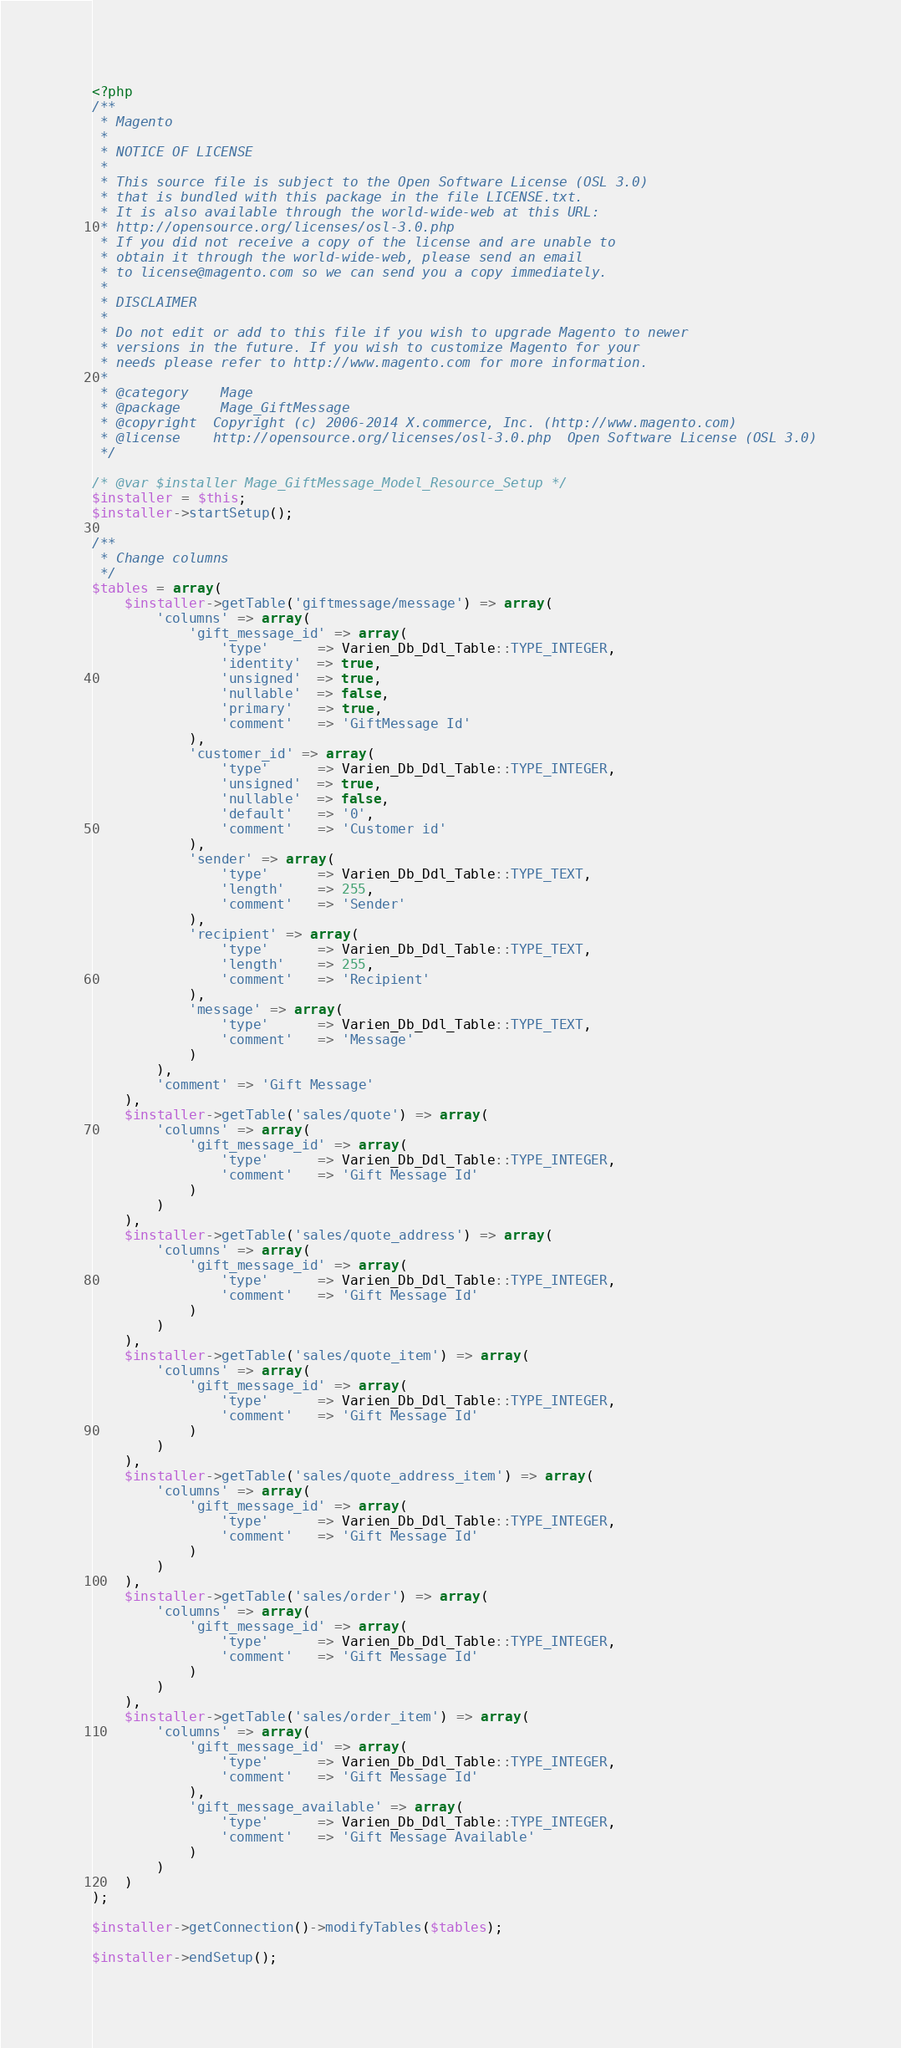Convert code to text. <code><loc_0><loc_0><loc_500><loc_500><_PHP_><?php
/**
 * Magento
 *
 * NOTICE OF LICENSE
 *
 * This source file is subject to the Open Software License (OSL 3.0)
 * that is bundled with this package in the file LICENSE.txt.
 * It is also available through the world-wide-web at this URL:
 * http://opensource.org/licenses/osl-3.0.php
 * If you did not receive a copy of the license and are unable to
 * obtain it through the world-wide-web, please send an email
 * to license@magento.com so we can send you a copy immediately.
 *
 * DISCLAIMER
 *
 * Do not edit or add to this file if you wish to upgrade Magento to newer
 * versions in the future. If you wish to customize Magento for your
 * needs please refer to http://www.magento.com for more information.
 *
 * @category    Mage
 * @package     Mage_GiftMessage
 * @copyright  Copyright (c) 2006-2014 X.commerce, Inc. (http://www.magento.com)
 * @license    http://opensource.org/licenses/osl-3.0.php  Open Software License (OSL 3.0)
 */

/* @var $installer Mage_GiftMessage_Model_Resource_Setup */
$installer = $this;
$installer->startSetup();

/**
 * Change columns
 */
$tables = array(
    $installer->getTable('giftmessage/message') => array(
        'columns' => array(
            'gift_message_id' => array(
                'type'      => Varien_Db_Ddl_Table::TYPE_INTEGER,
                'identity'  => true,
                'unsigned'  => true,
                'nullable'  => false,
                'primary'   => true,
                'comment'   => 'GiftMessage Id'
            ),
            'customer_id' => array(
                'type'      => Varien_Db_Ddl_Table::TYPE_INTEGER,
                'unsigned'  => true,
                'nullable'  => false,
                'default'   => '0',
                'comment'   => 'Customer id'
            ),
            'sender' => array(
                'type'      => Varien_Db_Ddl_Table::TYPE_TEXT,
                'length'    => 255,
                'comment'   => 'Sender'
            ),
            'recipient' => array(
                'type'      => Varien_Db_Ddl_Table::TYPE_TEXT,
                'length'    => 255,
                'comment'   => 'Recipient'
            ),
            'message' => array(
                'type'      => Varien_Db_Ddl_Table::TYPE_TEXT,
                'comment'   => 'Message'
            )
        ),
        'comment' => 'Gift Message'
    ),
    $installer->getTable('sales/quote') => array(
        'columns' => array(
            'gift_message_id' => array(
                'type'      => Varien_Db_Ddl_Table::TYPE_INTEGER,
                'comment'   => 'Gift Message Id'
            )
        )
    ),
    $installer->getTable('sales/quote_address') => array(
        'columns' => array(
            'gift_message_id' => array(
                'type'      => Varien_Db_Ddl_Table::TYPE_INTEGER,
                'comment'   => 'Gift Message Id'
            )
        )
    ),
    $installer->getTable('sales/quote_item') => array(
        'columns' => array(
            'gift_message_id' => array(
                'type'      => Varien_Db_Ddl_Table::TYPE_INTEGER,
                'comment'   => 'Gift Message Id'
            )
        )
    ),
    $installer->getTable('sales/quote_address_item') => array(
        'columns' => array(
            'gift_message_id' => array(
                'type'      => Varien_Db_Ddl_Table::TYPE_INTEGER,
                'comment'   => 'Gift Message Id'
            )
        )
    ),
    $installer->getTable('sales/order') => array(
        'columns' => array(
            'gift_message_id' => array(
                'type'      => Varien_Db_Ddl_Table::TYPE_INTEGER,
                'comment'   => 'Gift Message Id'
            )
        )
    ),
    $installer->getTable('sales/order_item') => array(
        'columns' => array(
            'gift_message_id' => array(
                'type'      => Varien_Db_Ddl_Table::TYPE_INTEGER,
                'comment'   => 'Gift Message Id'
            ),
            'gift_message_available' => array(
                'type'      => Varien_Db_Ddl_Table::TYPE_INTEGER,
                'comment'   => 'Gift Message Available'
            )
        )
    )
);

$installer->getConnection()->modifyTables($tables);

$installer->endSetup();
</code> 